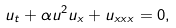Convert formula to latex. <formula><loc_0><loc_0><loc_500><loc_500>u _ { t } + \alpha u ^ { 2 } u _ { x } + u _ { x x x } = 0 ,</formula> 